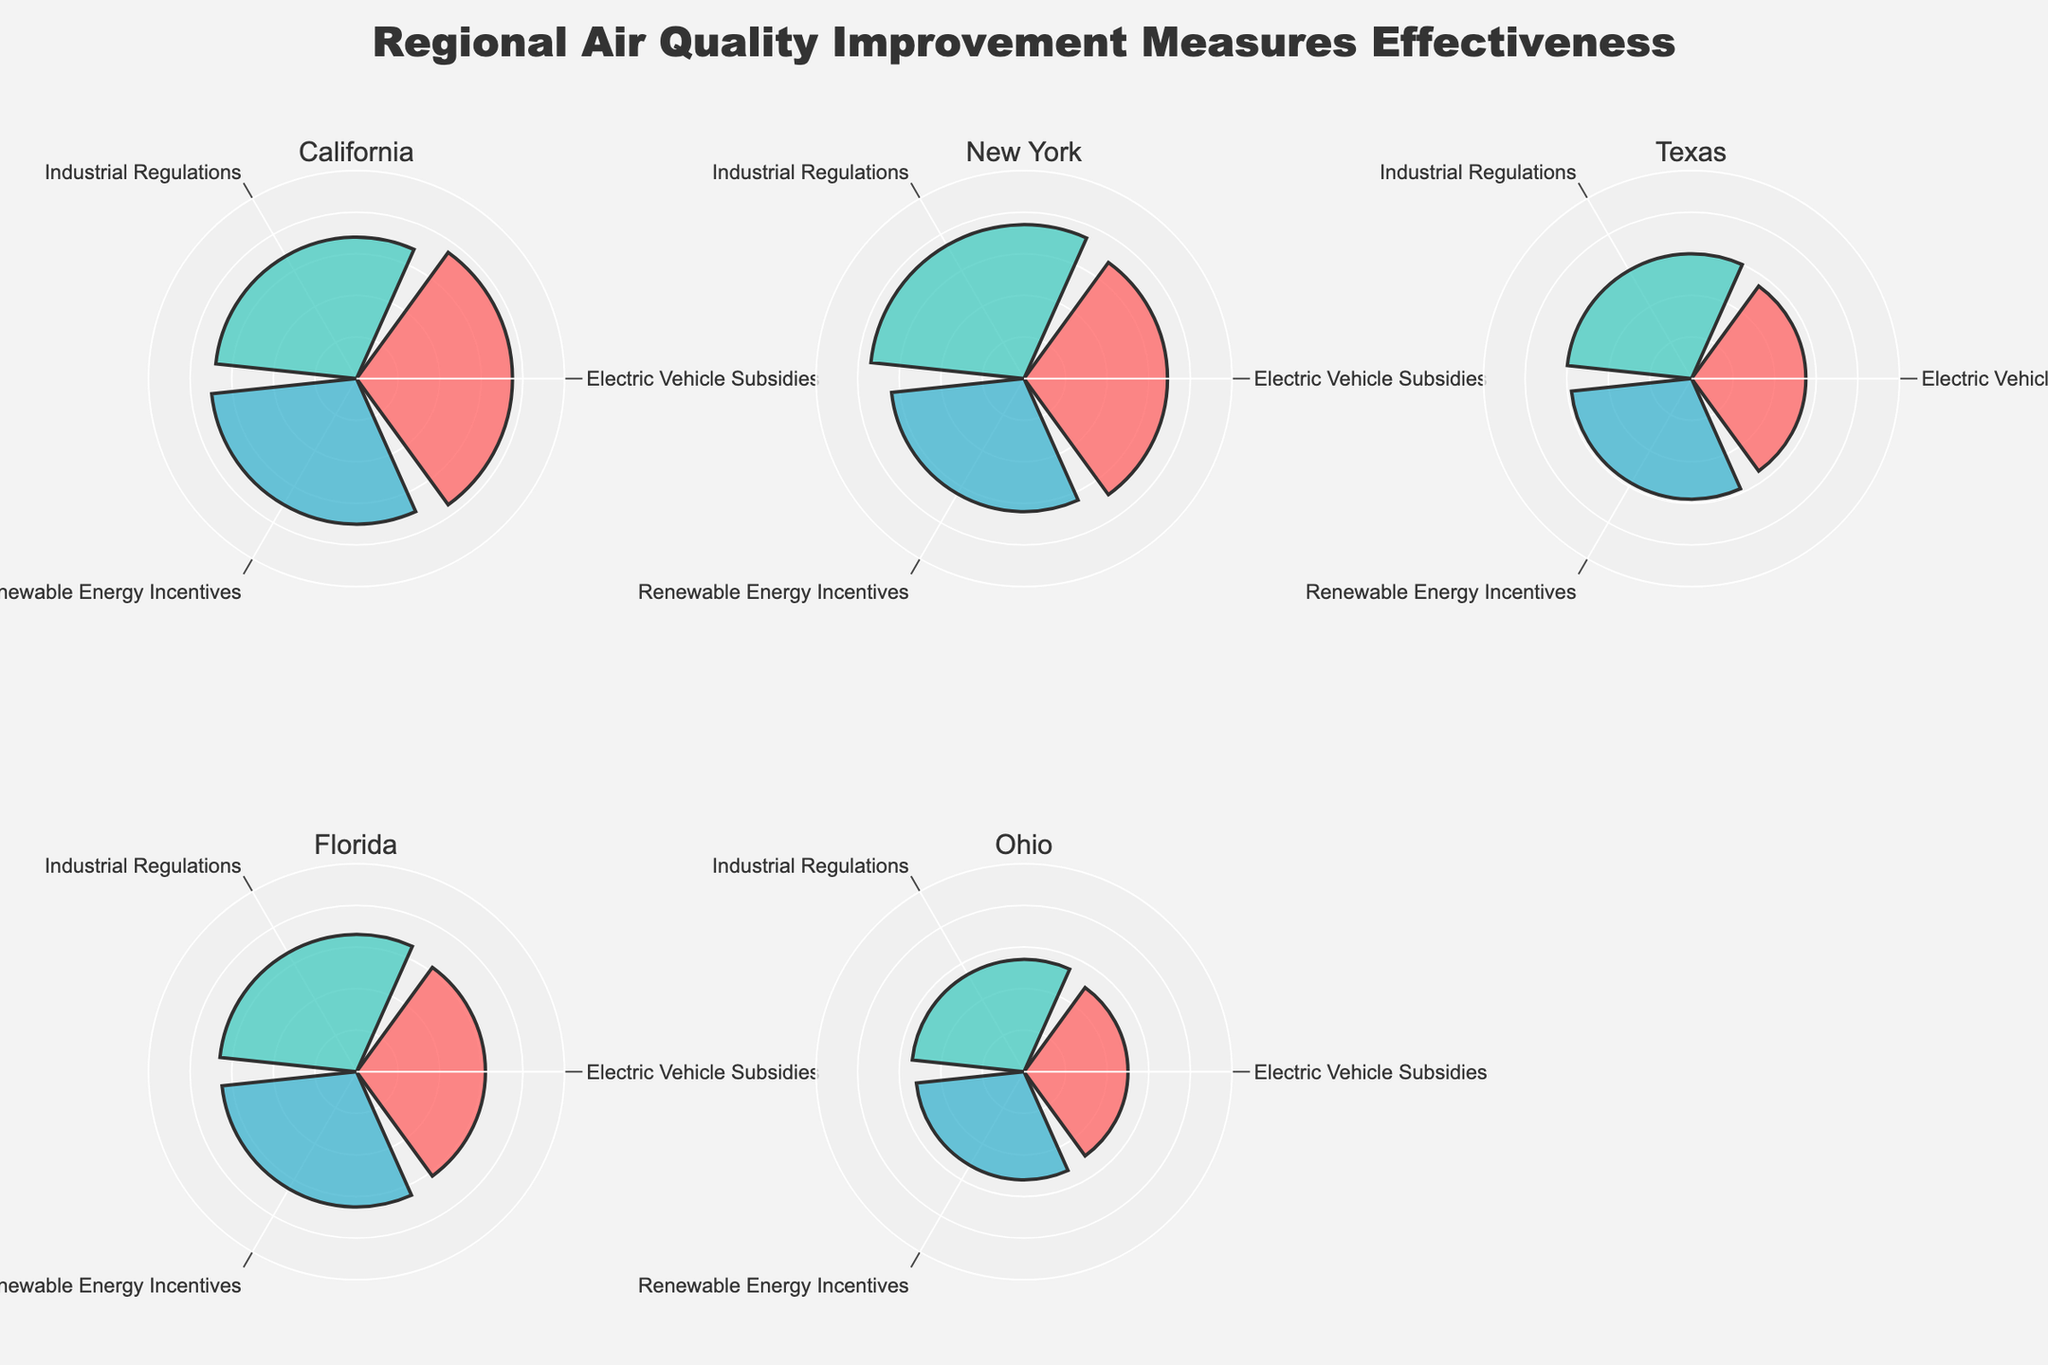How many regions are compared in the figure? The title states "Regional Air Quality Improvement Measures Effectiveness," and the subplot titles list the regions. Counting them, we have California, New York, Texas, Florida, and Ohio.
Answer: 5 Which region has the highest effectiveness for Electric Vehicle Subsidies? We need to look at the "Electric Vehicle Subsidies" bar in each subplot. California's bar is the highest at 0.75.
Answer: California For which measure does Ohio have the lowest effectiveness? Looking at Ohio's subplot, the shortest bar is for "Electric Vehicle Subsidies" with an effectiveness of 0.50.
Answer: Electric Vehicle Subsidies What is the average effectiveness of Industrial Regulations across all regions? Sum the effectiveness values for Industrial Regulations: (0.68 + 0.74 + 0.60 + 0.66 + 0.54) = 3.22. Divide by the number of regions (5): 3.22 / 5 = 0.644.
Answer: 0.644 Which measure has the most uniform effectiveness across all regions? Visually, we check which bars are closest in length across subplots. "Renewable Energy Incentives" seems most uniform with values: 0.70, 0.64, 0.58, 0.65, 0.52. Differences among them are smaller compared to other measures.
Answer: Renewable Energy Incentives In New York, which measure is more effective: Electric Vehicle Subsidies or Renewable Energy Incentives? In New York's subplot, "Electric Vehicle Subsidies" bar is higher (0.69) compared to "Renewable Energy Incentives" (0.64).
Answer: Electric Vehicle Subsidies Which region shows the most variation in effectiveness across the three measures? We need to assess the gaps between the bars within each region's subplot. Ohio has the largest variation, ranging from 0.50 to 0.54.
Answer: Ohio Compare the effectiveness of Renewable Energy Incentives between Texas and Florida. Which is higher? In Texas, the bar for "Renewable Energy Incentives" is at 0.58, and in Florida, it's at 0.65. Florida has the higher effectiveness.
Answer: Florida Is the effectiveness of Industrial Regulations in Florida higher than Electric Vehicle Subsidies in California? Florida's "Industrial Regulations" bar is at 0.66, while California's "Electric Vehicle Subsidies" bar is at 0.75. California is higher.
Answer: No Does any region have all measures with effectiveness above 0.6? Checking each region, all measures in California are above 0.6. The other regions have at least one measure below 0.6.
Answer: Yes, California 